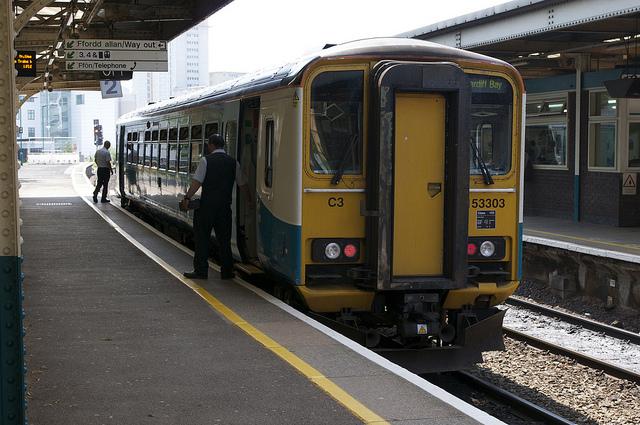Is this train moving?
Short answer required. No. What color is the train?
Concise answer only. Yellow. Is this a subway?
Give a very brief answer. No. Is the train moving?
Keep it brief. No. 